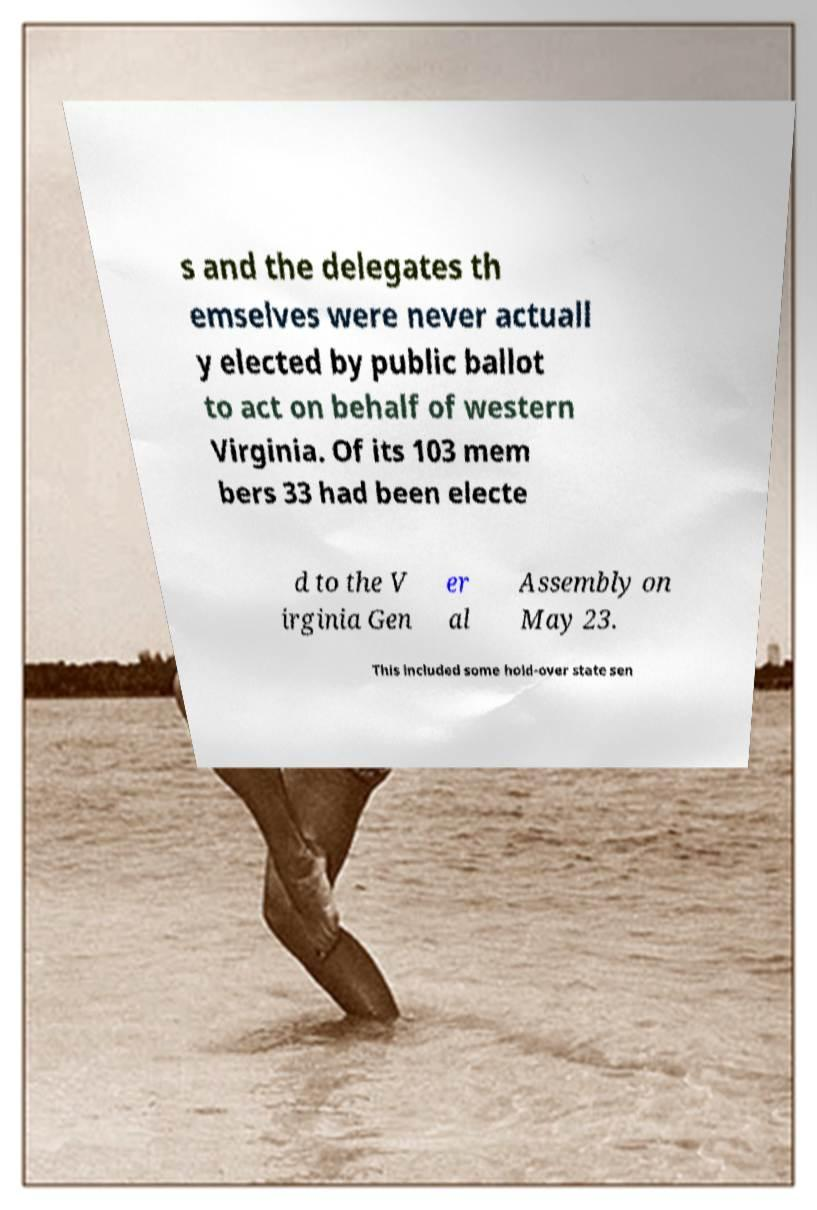I need the written content from this picture converted into text. Can you do that? s and the delegates th emselves were never actuall y elected by public ballot to act on behalf of western Virginia. Of its 103 mem bers 33 had been electe d to the V irginia Gen er al Assembly on May 23. This included some hold-over state sen 